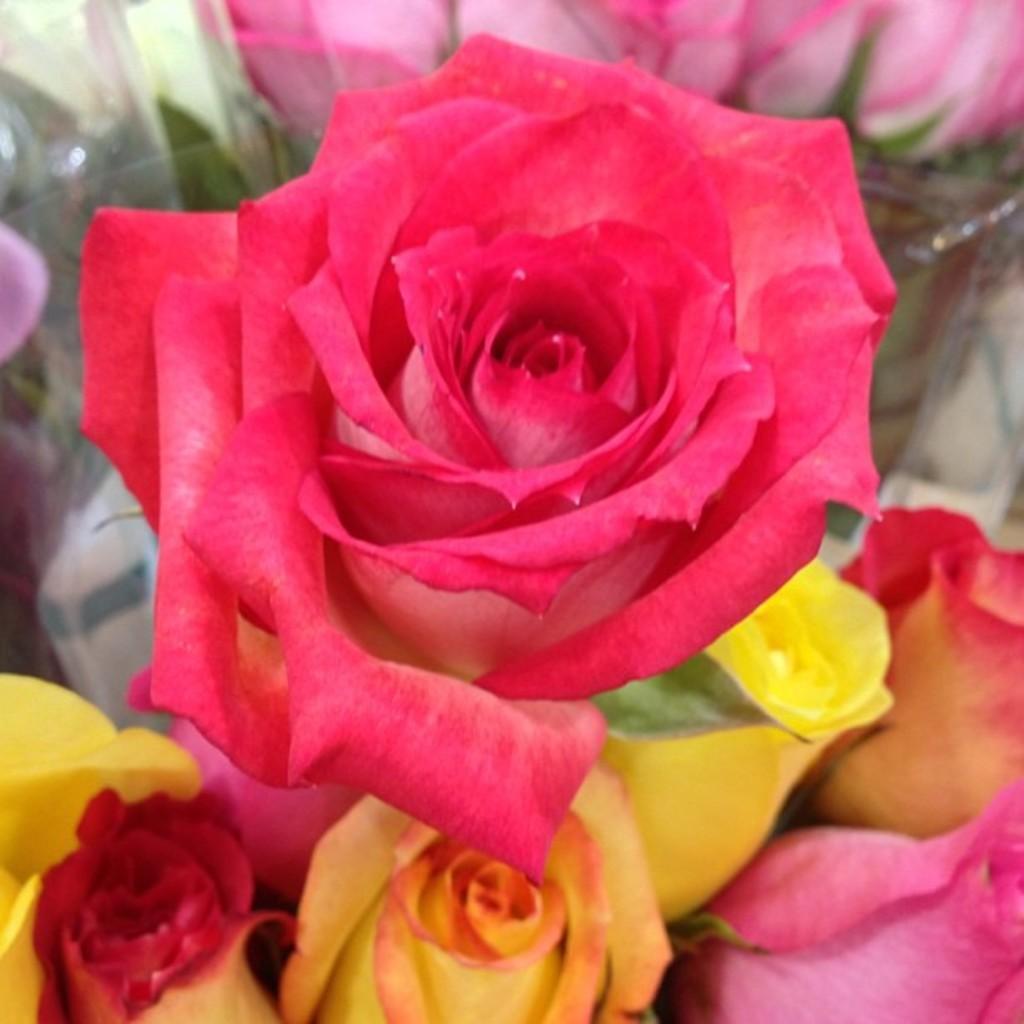In one or two sentences, can you explain what this image depicts? In this picture we can see colorful flowers and cover. 